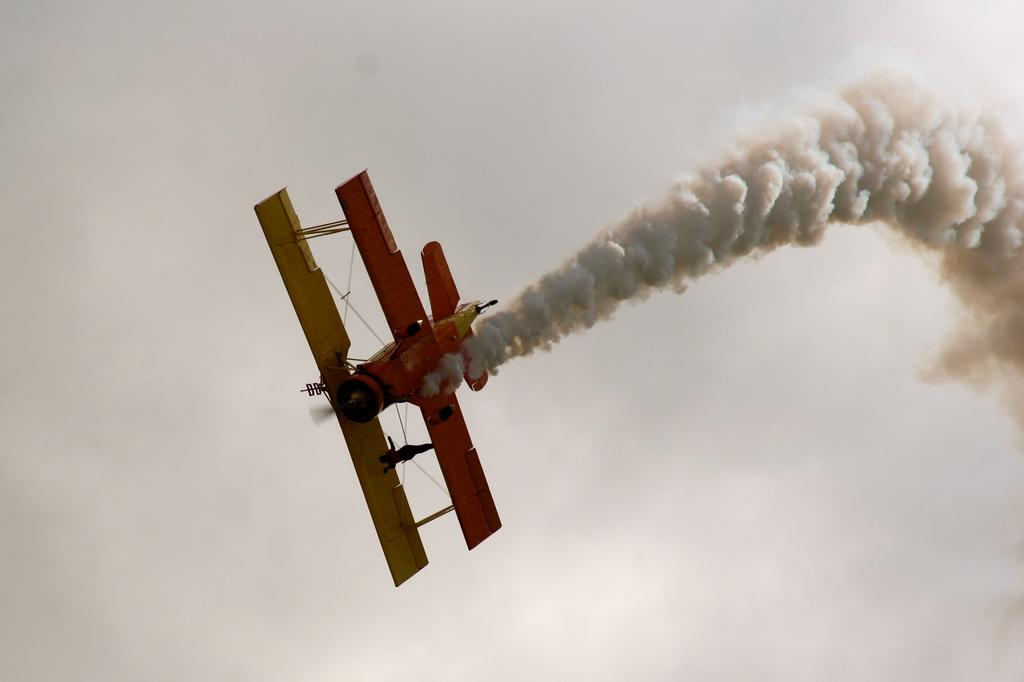What is the main subject in the center of the image? There is an aeroplane in the center of the image. What can be seen coming from the aeroplane? There is smoke in the image. What is visible in the background of the image? The sky is visible in the background of the image. Where is the girl sleeping in the image? There is no girl or sleeping figure present in the image. What is the aeroplane pointing at in the image? The aeroplane is not pointing at anything in the image; it is simply flying and producing smoke. 